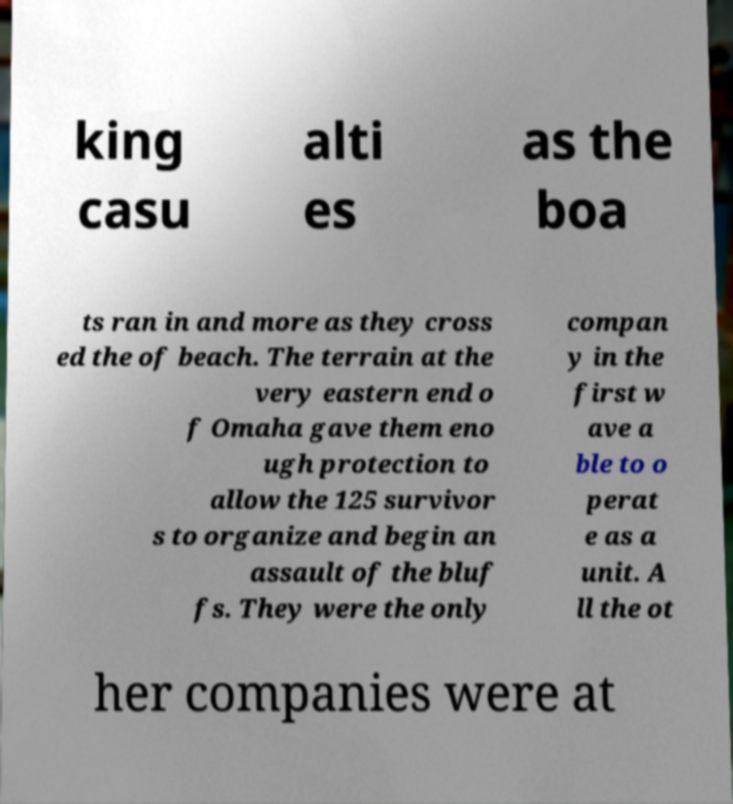Can you read and provide the text displayed in the image?This photo seems to have some interesting text. Can you extract and type it out for me? king casu alti es as the boa ts ran in and more as they cross ed the of beach. The terrain at the very eastern end o f Omaha gave them eno ugh protection to allow the 125 survivor s to organize and begin an assault of the bluf fs. They were the only compan y in the first w ave a ble to o perat e as a unit. A ll the ot her companies were at 